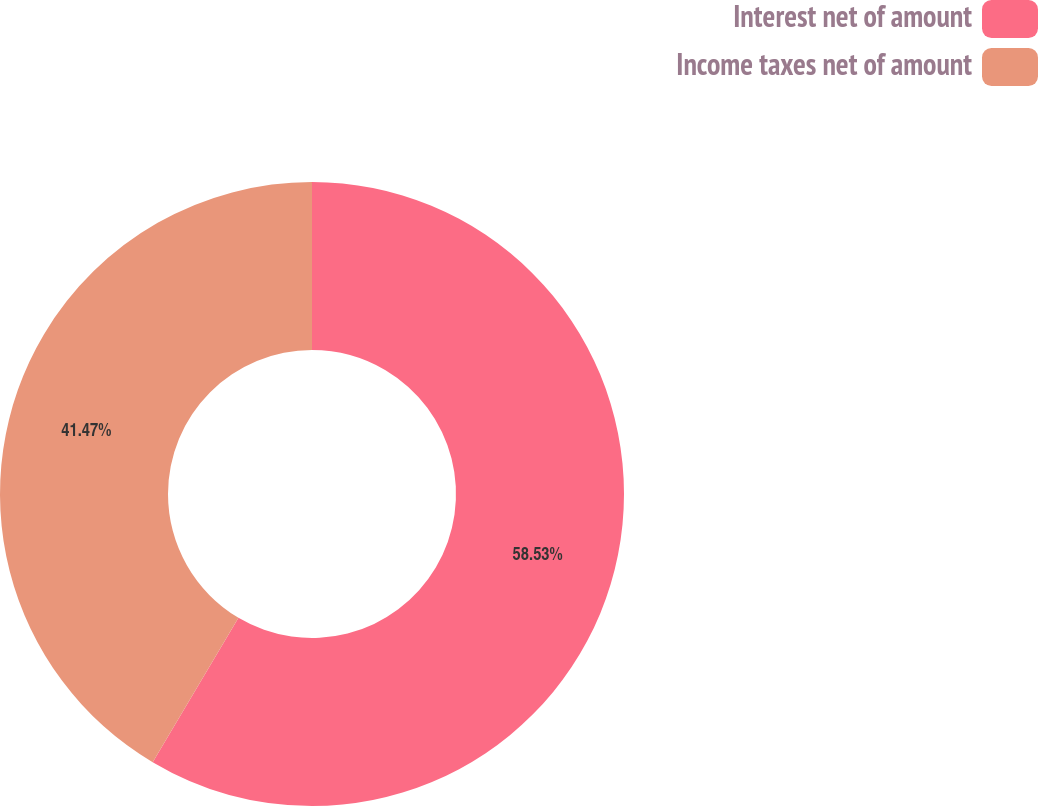<chart> <loc_0><loc_0><loc_500><loc_500><pie_chart><fcel>Interest net of amount<fcel>Income taxes net of amount<nl><fcel>58.53%<fcel>41.47%<nl></chart> 